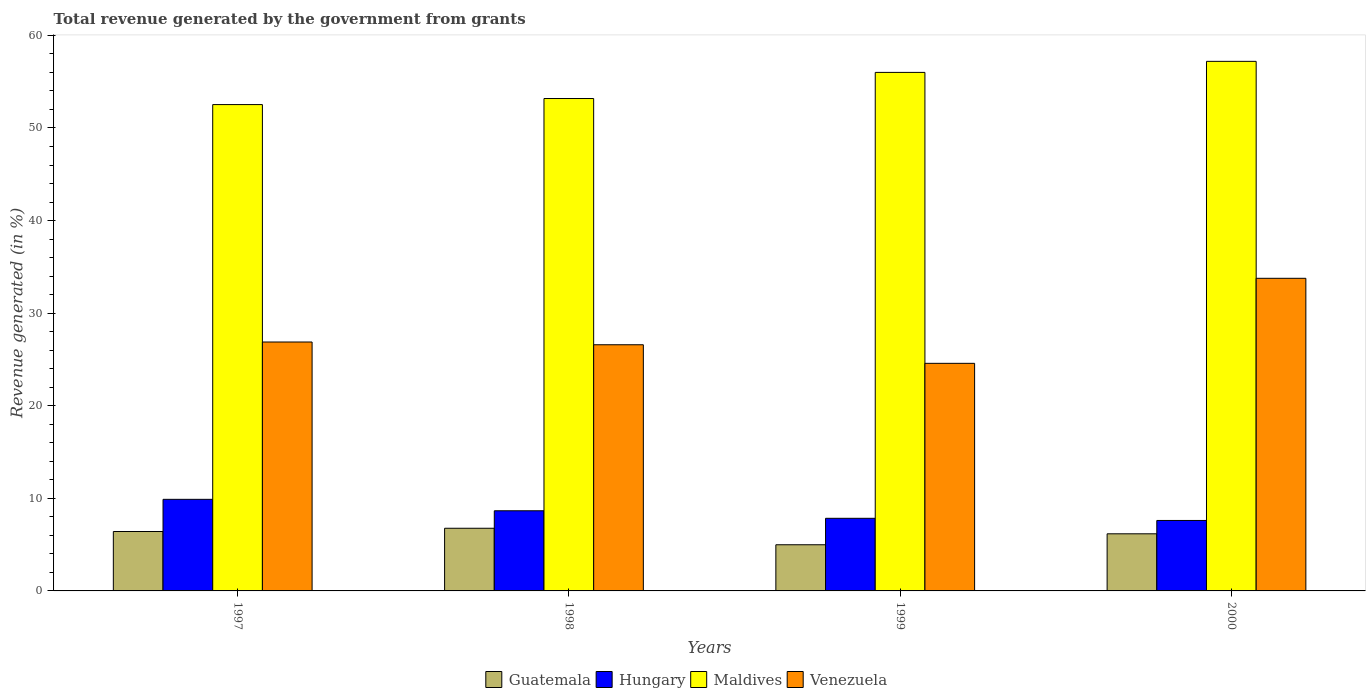How many different coloured bars are there?
Your answer should be very brief. 4. How many groups of bars are there?
Provide a short and direct response. 4. Are the number of bars per tick equal to the number of legend labels?
Provide a succinct answer. Yes. Are the number of bars on each tick of the X-axis equal?
Keep it short and to the point. Yes. How many bars are there on the 3rd tick from the left?
Keep it short and to the point. 4. In how many cases, is the number of bars for a given year not equal to the number of legend labels?
Your answer should be compact. 0. What is the total revenue generated in Hungary in 2000?
Ensure brevity in your answer.  7.61. Across all years, what is the maximum total revenue generated in Maldives?
Offer a terse response. 57.2. Across all years, what is the minimum total revenue generated in Maldives?
Your answer should be compact. 52.53. In which year was the total revenue generated in Hungary maximum?
Ensure brevity in your answer.  1997. What is the total total revenue generated in Hungary in the graph?
Ensure brevity in your answer.  34. What is the difference between the total revenue generated in Guatemala in 1997 and that in 1999?
Offer a terse response. 1.43. What is the difference between the total revenue generated in Guatemala in 1997 and the total revenue generated in Maldives in 1999?
Make the answer very short. -49.59. What is the average total revenue generated in Guatemala per year?
Provide a short and direct response. 6.08. In the year 1999, what is the difference between the total revenue generated in Hungary and total revenue generated in Guatemala?
Give a very brief answer. 2.86. In how many years, is the total revenue generated in Venezuela greater than 8 %?
Make the answer very short. 4. What is the ratio of the total revenue generated in Hungary in 1999 to that in 2000?
Your response must be concise. 1.03. Is the total revenue generated in Guatemala in 1997 less than that in 1999?
Your answer should be very brief. No. Is the difference between the total revenue generated in Hungary in 1997 and 2000 greater than the difference between the total revenue generated in Guatemala in 1997 and 2000?
Provide a succinct answer. Yes. What is the difference between the highest and the second highest total revenue generated in Maldives?
Provide a short and direct response. 1.19. What is the difference between the highest and the lowest total revenue generated in Maldives?
Ensure brevity in your answer.  4.67. What does the 4th bar from the left in 2000 represents?
Your answer should be very brief. Venezuela. What does the 2nd bar from the right in 1999 represents?
Provide a succinct answer. Maldives. How many bars are there?
Provide a succinct answer. 16. Are all the bars in the graph horizontal?
Provide a succinct answer. No. Are the values on the major ticks of Y-axis written in scientific E-notation?
Ensure brevity in your answer.  No. Does the graph contain any zero values?
Keep it short and to the point. No. What is the title of the graph?
Your answer should be compact. Total revenue generated by the government from grants. Does "West Bank and Gaza" appear as one of the legend labels in the graph?
Give a very brief answer. No. What is the label or title of the X-axis?
Your answer should be compact. Years. What is the label or title of the Y-axis?
Provide a short and direct response. Revenue generated (in %). What is the Revenue generated (in %) in Guatemala in 1997?
Ensure brevity in your answer.  6.42. What is the Revenue generated (in %) in Hungary in 1997?
Ensure brevity in your answer.  9.89. What is the Revenue generated (in %) in Maldives in 1997?
Your answer should be compact. 52.53. What is the Revenue generated (in %) in Venezuela in 1997?
Make the answer very short. 26.88. What is the Revenue generated (in %) in Guatemala in 1998?
Offer a terse response. 6.77. What is the Revenue generated (in %) of Hungary in 1998?
Offer a terse response. 8.66. What is the Revenue generated (in %) in Maldives in 1998?
Give a very brief answer. 53.18. What is the Revenue generated (in %) in Venezuela in 1998?
Ensure brevity in your answer.  26.59. What is the Revenue generated (in %) in Guatemala in 1999?
Make the answer very short. 4.99. What is the Revenue generated (in %) of Hungary in 1999?
Provide a succinct answer. 7.84. What is the Revenue generated (in %) in Maldives in 1999?
Offer a very short reply. 56. What is the Revenue generated (in %) of Venezuela in 1999?
Your answer should be compact. 24.58. What is the Revenue generated (in %) in Guatemala in 2000?
Your response must be concise. 6.17. What is the Revenue generated (in %) of Hungary in 2000?
Offer a terse response. 7.61. What is the Revenue generated (in %) in Maldives in 2000?
Your response must be concise. 57.2. What is the Revenue generated (in %) in Venezuela in 2000?
Your answer should be compact. 33.76. Across all years, what is the maximum Revenue generated (in %) in Guatemala?
Offer a terse response. 6.77. Across all years, what is the maximum Revenue generated (in %) in Hungary?
Give a very brief answer. 9.89. Across all years, what is the maximum Revenue generated (in %) in Maldives?
Your response must be concise. 57.2. Across all years, what is the maximum Revenue generated (in %) of Venezuela?
Your answer should be very brief. 33.76. Across all years, what is the minimum Revenue generated (in %) of Guatemala?
Your answer should be very brief. 4.99. Across all years, what is the minimum Revenue generated (in %) in Hungary?
Offer a terse response. 7.61. Across all years, what is the minimum Revenue generated (in %) of Maldives?
Offer a very short reply. 52.53. Across all years, what is the minimum Revenue generated (in %) of Venezuela?
Make the answer very short. 24.58. What is the total Revenue generated (in %) in Guatemala in the graph?
Your response must be concise. 24.34. What is the total Revenue generated (in %) of Hungary in the graph?
Offer a very short reply. 34. What is the total Revenue generated (in %) of Maldives in the graph?
Keep it short and to the point. 218.91. What is the total Revenue generated (in %) of Venezuela in the graph?
Ensure brevity in your answer.  111.82. What is the difference between the Revenue generated (in %) of Guatemala in 1997 and that in 1998?
Your response must be concise. -0.35. What is the difference between the Revenue generated (in %) in Hungary in 1997 and that in 1998?
Provide a short and direct response. 1.24. What is the difference between the Revenue generated (in %) of Maldives in 1997 and that in 1998?
Provide a succinct answer. -0.65. What is the difference between the Revenue generated (in %) in Venezuela in 1997 and that in 1998?
Your answer should be compact. 0.3. What is the difference between the Revenue generated (in %) in Guatemala in 1997 and that in 1999?
Provide a short and direct response. 1.43. What is the difference between the Revenue generated (in %) in Hungary in 1997 and that in 1999?
Make the answer very short. 2.05. What is the difference between the Revenue generated (in %) in Maldives in 1997 and that in 1999?
Offer a very short reply. -3.48. What is the difference between the Revenue generated (in %) in Venezuela in 1997 and that in 1999?
Your answer should be compact. 2.3. What is the difference between the Revenue generated (in %) of Guatemala in 1997 and that in 2000?
Offer a very short reply. 0.25. What is the difference between the Revenue generated (in %) of Hungary in 1997 and that in 2000?
Provide a short and direct response. 2.28. What is the difference between the Revenue generated (in %) in Maldives in 1997 and that in 2000?
Give a very brief answer. -4.67. What is the difference between the Revenue generated (in %) of Venezuela in 1997 and that in 2000?
Offer a terse response. -6.88. What is the difference between the Revenue generated (in %) of Guatemala in 1998 and that in 1999?
Keep it short and to the point. 1.78. What is the difference between the Revenue generated (in %) in Hungary in 1998 and that in 1999?
Your answer should be very brief. 0.81. What is the difference between the Revenue generated (in %) in Maldives in 1998 and that in 1999?
Offer a very short reply. -2.82. What is the difference between the Revenue generated (in %) of Venezuela in 1998 and that in 1999?
Your answer should be compact. 2.01. What is the difference between the Revenue generated (in %) in Guatemala in 1998 and that in 2000?
Give a very brief answer. 0.6. What is the difference between the Revenue generated (in %) of Hungary in 1998 and that in 2000?
Provide a short and direct response. 1.05. What is the difference between the Revenue generated (in %) in Maldives in 1998 and that in 2000?
Make the answer very short. -4.01. What is the difference between the Revenue generated (in %) of Venezuela in 1998 and that in 2000?
Provide a succinct answer. -7.18. What is the difference between the Revenue generated (in %) in Guatemala in 1999 and that in 2000?
Provide a succinct answer. -1.18. What is the difference between the Revenue generated (in %) in Hungary in 1999 and that in 2000?
Offer a terse response. 0.23. What is the difference between the Revenue generated (in %) in Maldives in 1999 and that in 2000?
Provide a succinct answer. -1.19. What is the difference between the Revenue generated (in %) of Venezuela in 1999 and that in 2000?
Keep it short and to the point. -9.18. What is the difference between the Revenue generated (in %) in Guatemala in 1997 and the Revenue generated (in %) in Hungary in 1998?
Provide a short and direct response. -2.24. What is the difference between the Revenue generated (in %) of Guatemala in 1997 and the Revenue generated (in %) of Maldives in 1998?
Make the answer very short. -46.77. What is the difference between the Revenue generated (in %) of Guatemala in 1997 and the Revenue generated (in %) of Venezuela in 1998?
Make the answer very short. -20.17. What is the difference between the Revenue generated (in %) of Hungary in 1997 and the Revenue generated (in %) of Maldives in 1998?
Provide a succinct answer. -43.29. What is the difference between the Revenue generated (in %) in Hungary in 1997 and the Revenue generated (in %) in Venezuela in 1998?
Provide a short and direct response. -16.69. What is the difference between the Revenue generated (in %) in Maldives in 1997 and the Revenue generated (in %) in Venezuela in 1998?
Provide a short and direct response. 25.94. What is the difference between the Revenue generated (in %) in Guatemala in 1997 and the Revenue generated (in %) in Hungary in 1999?
Provide a short and direct response. -1.43. What is the difference between the Revenue generated (in %) of Guatemala in 1997 and the Revenue generated (in %) of Maldives in 1999?
Ensure brevity in your answer.  -49.59. What is the difference between the Revenue generated (in %) of Guatemala in 1997 and the Revenue generated (in %) of Venezuela in 1999?
Keep it short and to the point. -18.16. What is the difference between the Revenue generated (in %) of Hungary in 1997 and the Revenue generated (in %) of Maldives in 1999?
Your response must be concise. -46.11. What is the difference between the Revenue generated (in %) of Hungary in 1997 and the Revenue generated (in %) of Venezuela in 1999?
Keep it short and to the point. -14.69. What is the difference between the Revenue generated (in %) in Maldives in 1997 and the Revenue generated (in %) in Venezuela in 1999?
Ensure brevity in your answer.  27.95. What is the difference between the Revenue generated (in %) in Guatemala in 1997 and the Revenue generated (in %) in Hungary in 2000?
Give a very brief answer. -1.19. What is the difference between the Revenue generated (in %) of Guatemala in 1997 and the Revenue generated (in %) of Maldives in 2000?
Provide a short and direct response. -50.78. What is the difference between the Revenue generated (in %) in Guatemala in 1997 and the Revenue generated (in %) in Venezuela in 2000?
Give a very brief answer. -27.35. What is the difference between the Revenue generated (in %) of Hungary in 1997 and the Revenue generated (in %) of Maldives in 2000?
Your answer should be very brief. -47.3. What is the difference between the Revenue generated (in %) in Hungary in 1997 and the Revenue generated (in %) in Venezuela in 2000?
Provide a short and direct response. -23.87. What is the difference between the Revenue generated (in %) in Maldives in 1997 and the Revenue generated (in %) in Venezuela in 2000?
Your answer should be very brief. 18.76. What is the difference between the Revenue generated (in %) of Guatemala in 1998 and the Revenue generated (in %) of Hungary in 1999?
Your response must be concise. -1.08. What is the difference between the Revenue generated (in %) of Guatemala in 1998 and the Revenue generated (in %) of Maldives in 1999?
Your answer should be compact. -49.23. What is the difference between the Revenue generated (in %) in Guatemala in 1998 and the Revenue generated (in %) in Venezuela in 1999?
Offer a terse response. -17.81. What is the difference between the Revenue generated (in %) in Hungary in 1998 and the Revenue generated (in %) in Maldives in 1999?
Offer a terse response. -47.35. What is the difference between the Revenue generated (in %) of Hungary in 1998 and the Revenue generated (in %) of Venezuela in 1999?
Provide a short and direct response. -15.92. What is the difference between the Revenue generated (in %) of Maldives in 1998 and the Revenue generated (in %) of Venezuela in 1999?
Provide a succinct answer. 28.6. What is the difference between the Revenue generated (in %) in Guatemala in 1998 and the Revenue generated (in %) in Hungary in 2000?
Offer a terse response. -0.84. What is the difference between the Revenue generated (in %) in Guatemala in 1998 and the Revenue generated (in %) in Maldives in 2000?
Ensure brevity in your answer.  -50.43. What is the difference between the Revenue generated (in %) of Guatemala in 1998 and the Revenue generated (in %) of Venezuela in 2000?
Your answer should be compact. -27. What is the difference between the Revenue generated (in %) in Hungary in 1998 and the Revenue generated (in %) in Maldives in 2000?
Your answer should be compact. -48.54. What is the difference between the Revenue generated (in %) in Hungary in 1998 and the Revenue generated (in %) in Venezuela in 2000?
Make the answer very short. -25.11. What is the difference between the Revenue generated (in %) in Maldives in 1998 and the Revenue generated (in %) in Venezuela in 2000?
Make the answer very short. 19.42. What is the difference between the Revenue generated (in %) in Guatemala in 1999 and the Revenue generated (in %) in Hungary in 2000?
Keep it short and to the point. -2.62. What is the difference between the Revenue generated (in %) of Guatemala in 1999 and the Revenue generated (in %) of Maldives in 2000?
Offer a terse response. -52.21. What is the difference between the Revenue generated (in %) in Guatemala in 1999 and the Revenue generated (in %) in Venezuela in 2000?
Make the answer very short. -28.78. What is the difference between the Revenue generated (in %) of Hungary in 1999 and the Revenue generated (in %) of Maldives in 2000?
Make the answer very short. -49.35. What is the difference between the Revenue generated (in %) of Hungary in 1999 and the Revenue generated (in %) of Venezuela in 2000?
Give a very brief answer. -25.92. What is the difference between the Revenue generated (in %) in Maldives in 1999 and the Revenue generated (in %) in Venezuela in 2000?
Your answer should be very brief. 22.24. What is the average Revenue generated (in %) of Guatemala per year?
Provide a succinct answer. 6.08. What is the average Revenue generated (in %) of Hungary per year?
Make the answer very short. 8.5. What is the average Revenue generated (in %) in Maldives per year?
Keep it short and to the point. 54.73. What is the average Revenue generated (in %) in Venezuela per year?
Ensure brevity in your answer.  27.95. In the year 1997, what is the difference between the Revenue generated (in %) in Guatemala and Revenue generated (in %) in Hungary?
Keep it short and to the point. -3.48. In the year 1997, what is the difference between the Revenue generated (in %) in Guatemala and Revenue generated (in %) in Maldives?
Make the answer very short. -46.11. In the year 1997, what is the difference between the Revenue generated (in %) of Guatemala and Revenue generated (in %) of Venezuela?
Ensure brevity in your answer.  -20.47. In the year 1997, what is the difference between the Revenue generated (in %) of Hungary and Revenue generated (in %) of Maldives?
Your response must be concise. -42.64. In the year 1997, what is the difference between the Revenue generated (in %) of Hungary and Revenue generated (in %) of Venezuela?
Keep it short and to the point. -16.99. In the year 1997, what is the difference between the Revenue generated (in %) in Maldives and Revenue generated (in %) in Venezuela?
Keep it short and to the point. 25.64. In the year 1998, what is the difference between the Revenue generated (in %) in Guatemala and Revenue generated (in %) in Hungary?
Your answer should be very brief. -1.89. In the year 1998, what is the difference between the Revenue generated (in %) of Guatemala and Revenue generated (in %) of Maldives?
Provide a short and direct response. -46.41. In the year 1998, what is the difference between the Revenue generated (in %) in Guatemala and Revenue generated (in %) in Venezuela?
Your response must be concise. -19.82. In the year 1998, what is the difference between the Revenue generated (in %) in Hungary and Revenue generated (in %) in Maldives?
Offer a very short reply. -44.53. In the year 1998, what is the difference between the Revenue generated (in %) in Hungary and Revenue generated (in %) in Venezuela?
Keep it short and to the point. -17.93. In the year 1998, what is the difference between the Revenue generated (in %) of Maldives and Revenue generated (in %) of Venezuela?
Give a very brief answer. 26.6. In the year 1999, what is the difference between the Revenue generated (in %) of Guatemala and Revenue generated (in %) of Hungary?
Give a very brief answer. -2.86. In the year 1999, what is the difference between the Revenue generated (in %) of Guatemala and Revenue generated (in %) of Maldives?
Ensure brevity in your answer.  -51.02. In the year 1999, what is the difference between the Revenue generated (in %) in Guatemala and Revenue generated (in %) in Venezuela?
Provide a short and direct response. -19.59. In the year 1999, what is the difference between the Revenue generated (in %) in Hungary and Revenue generated (in %) in Maldives?
Provide a succinct answer. -48.16. In the year 1999, what is the difference between the Revenue generated (in %) in Hungary and Revenue generated (in %) in Venezuela?
Your answer should be compact. -16.74. In the year 1999, what is the difference between the Revenue generated (in %) in Maldives and Revenue generated (in %) in Venezuela?
Offer a terse response. 31.42. In the year 2000, what is the difference between the Revenue generated (in %) of Guatemala and Revenue generated (in %) of Hungary?
Make the answer very short. -1.44. In the year 2000, what is the difference between the Revenue generated (in %) in Guatemala and Revenue generated (in %) in Maldives?
Keep it short and to the point. -51.03. In the year 2000, what is the difference between the Revenue generated (in %) in Guatemala and Revenue generated (in %) in Venezuela?
Offer a terse response. -27.6. In the year 2000, what is the difference between the Revenue generated (in %) in Hungary and Revenue generated (in %) in Maldives?
Make the answer very short. -49.59. In the year 2000, what is the difference between the Revenue generated (in %) of Hungary and Revenue generated (in %) of Venezuela?
Offer a terse response. -26.15. In the year 2000, what is the difference between the Revenue generated (in %) of Maldives and Revenue generated (in %) of Venezuela?
Keep it short and to the point. 23.43. What is the ratio of the Revenue generated (in %) of Guatemala in 1997 to that in 1998?
Offer a very short reply. 0.95. What is the ratio of the Revenue generated (in %) of Hungary in 1997 to that in 1998?
Provide a short and direct response. 1.14. What is the ratio of the Revenue generated (in %) of Maldives in 1997 to that in 1998?
Provide a succinct answer. 0.99. What is the ratio of the Revenue generated (in %) in Venezuela in 1997 to that in 1998?
Make the answer very short. 1.01. What is the ratio of the Revenue generated (in %) in Guatemala in 1997 to that in 1999?
Your response must be concise. 1.29. What is the ratio of the Revenue generated (in %) of Hungary in 1997 to that in 1999?
Offer a terse response. 1.26. What is the ratio of the Revenue generated (in %) of Maldives in 1997 to that in 1999?
Ensure brevity in your answer.  0.94. What is the ratio of the Revenue generated (in %) of Venezuela in 1997 to that in 1999?
Keep it short and to the point. 1.09. What is the ratio of the Revenue generated (in %) of Hungary in 1997 to that in 2000?
Give a very brief answer. 1.3. What is the ratio of the Revenue generated (in %) of Maldives in 1997 to that in 2000?
Your response must be concise. 0.92. What is the ratio of the Revenue generated (in %) in Venezuela in 1997 to that in 2000?
Your response must be concise. 0.8. What is the ratio of the Revenue generated (in %) of Guatemala in 1998 to that in 1999?
Give a very brief answer. 1.36. What is the ratio of the Revenue generated (in %) of Hungary in 1998 to that in 1999?
Give a very brief answer. 1.1. What is the ratio of the Revenue generated (in %) of Maldives in 1998 to that in 1999?
Your answer should be compact. 0.95. What is the ratio of the Revenue generated (in %) of Venezuela in 1998 to that in 1999?
Provide a succinct answer. 1.08. What is the ratio of the Revenue generated (in %) in Guatemala in 1998 to that in 2000?
Provide a succinct answer. 1.1. What is the ratio of the Revenue generated (in %) in Hungary in 1998 to that in 2000?
Your response must be concise. 1.14. What is the ratio of the Revenue generated (in %) of Maldives in 1998 to that in 2000?
Ensure brevity in your answer.  0.93. What is the ratio of the Revenue generated (in %) of Venezuela in 1998 to that in 2000?
Your response must be concise. 0.79. What is the ratio of the Revenue generated (in %) in Guatemala in 1999 to that in 2000?
Ensure brevity in your answer.  0.81. What is the ratio of the Revenue generated (in %) of Hungary in 1999 to that in 2000?
Your answer should be compact. 1.03. What is the ratio of the Revenue generated (in %) in Maldives in 1999 to that in 2000?
Provide a succinct answer. 0.98. What is the ratio of the Revenue generated (in %) in Venezuela in 1999 to that in 2000?
Give a very brief answer. 0.73. What is the difference between the highest and the second highest Revenue generated (in %) of Guatemala?
Your response must be concise. 0.35. What is the difference between the highest and the second highest Revenue generated (in %) of Hungary?
Your answer should be very brief. 1.24. What is the difference between the highest and the second highest Revenue generated (in %) of Maldives?
Make the answer very short. 1.19. What is the difference between the highest and the second highest Revenue generated (in %) of Venezuela?
Give a very brief answer. 6.88. What is the difference between the highest and the lowest Revenue generated (in %) in Guatemala?
Provide a succinct answer. 1.78. What is the difference between the highest and the lowest Revenue generated (in %) in Hungary?
Keep it short and to the point. 2.28. What is the difference between the highest and the lowest Revenue generated (in %) in Maldives?
Provide a succinct answer. 4.67. What is the difference between the highest and the lowest Revenue generated (in %) in Venezuela?
Offer a terse response. 9.18. 